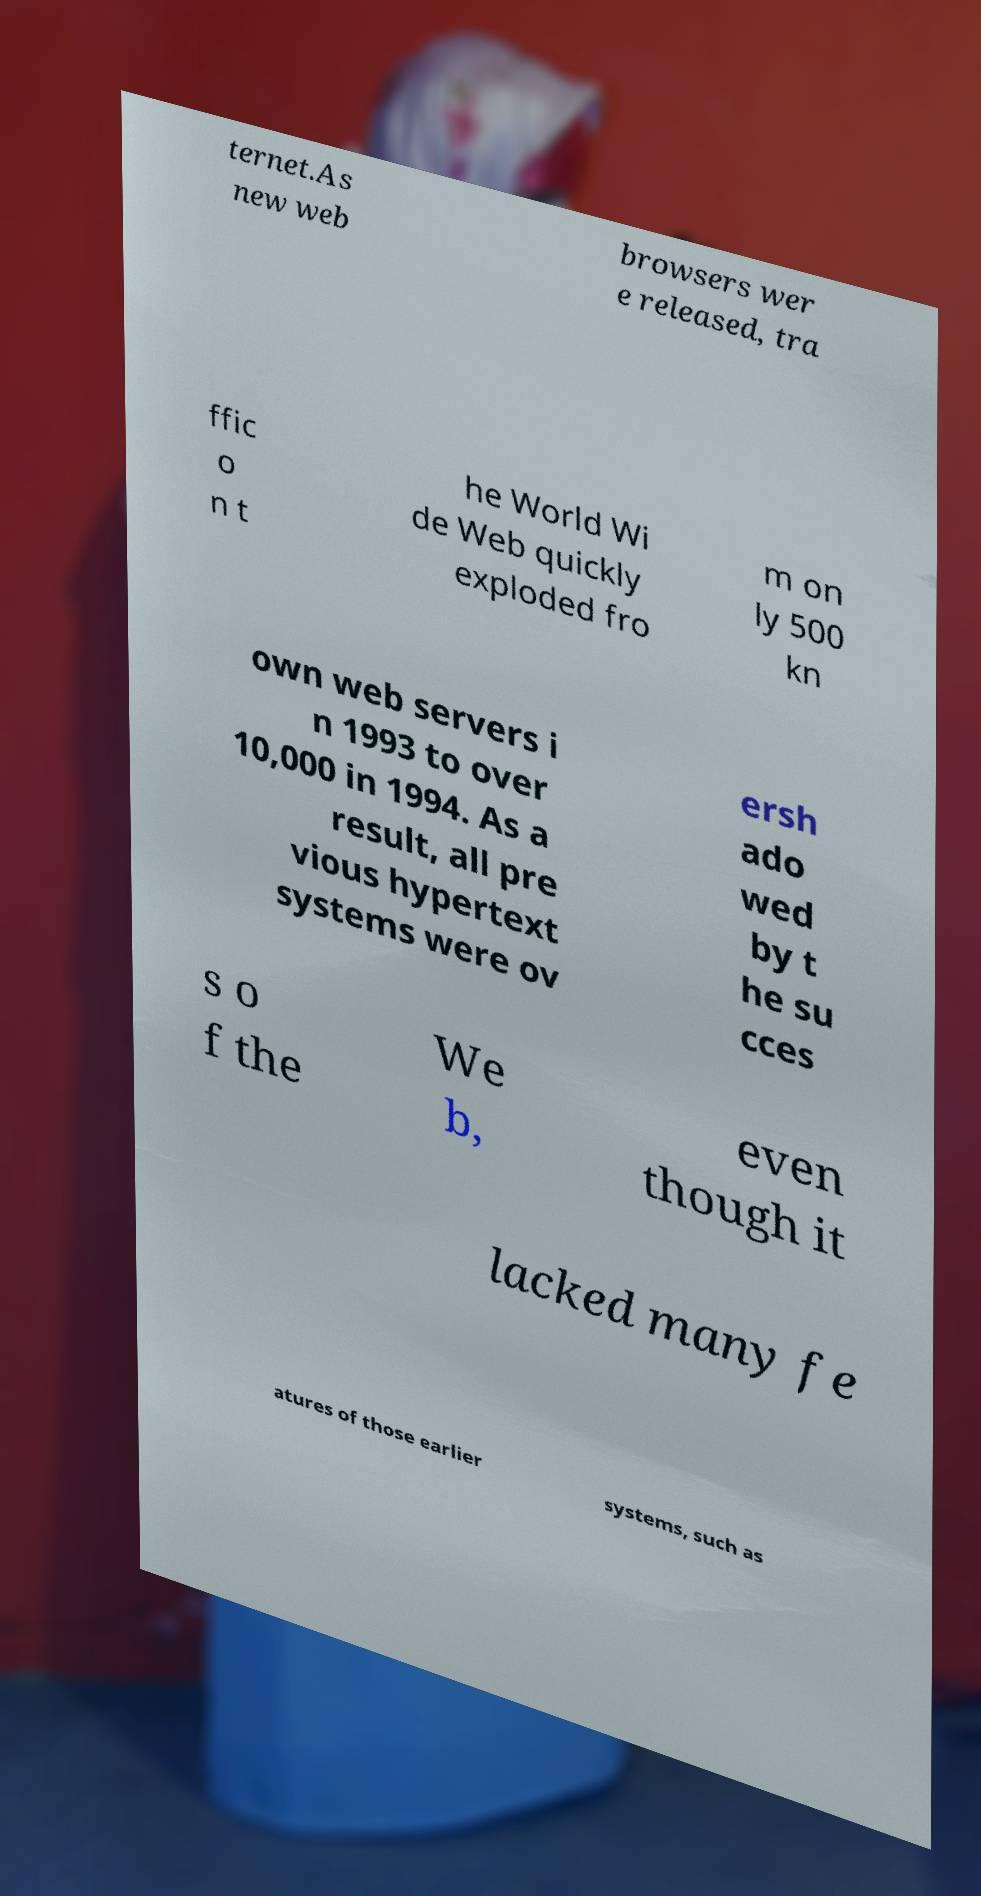Could you assist in decoding the text presented in this image and type it out clearly? ternet.As new web browsers wer e released, tra ffic o n t he World Wi de Web quickly exploded fro m on ly 500 kn own web servers i n 1993 to over 10,000 in 1994. As a result, all pre vious hypertext systems were ov ersh ado wed by t he su cces s o f the We b, even though it lacked many fe atures of those earlier systems, such as 